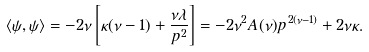<formula> <loc_0><loc_0><loc_500><loc_500>\langle \psi , \psi \rangle = - 2 \nu \left [ \kappa ( \nu - 1 ) + \frac { \nu \lambda } { p ^ { 2 } } \right ] = - 2 \nu ^ { 2 } A ( \nu ) p ^ { 2 ( \nu - 1 ) } + 2 \nu \kappa .</formula> 